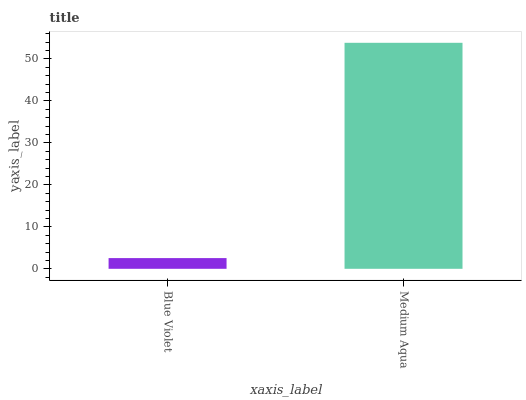Is Medium Aqua the minimum?
Answer yes or no. No. Is Medium Aqua greater than Blue Violet?
Answer yes or no. Yes. Is Blue Violet less than Medium Aqua?
Answer yes or no. Yes. Is Blue Violet greater than Medium Aqua?
Answer yes or no. No. Is Medium Aqua less than Blue Violet?
Answer yes or no. No. Is Medium Aqua the high median?
Answer yes or no. Yes. Is Blue Violet the low median?
Answer yes or no. Yes. Is Blue Violet the high median?
Answer yes or no. No. Is Medium Aqua the low median?
Answer yes or no. No. 